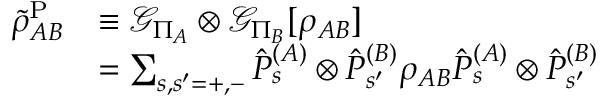<formula> <loc_0><loc_0><loc_500><loc_500>\begin{array} { r l } { \tilde { \rho } _ { A B } ^ { P } } & { \equiv \mathcal { G } _ { \Pi _ { A } } \otimes \mathcal { G } _ { \Pi _ { B } } [ \rho _ { A B } ] } \\ & { = \sum _ { s , s ^ { \prime } = + , - } \hat { P } _ { s } ^ { ( A ) } \otimes \hat { P } _ { s ^ { \prime } } ^ { ( B ) } \rho _ { A B } \hat { P } _ { s } ^ { ( A ) } \otimes \hat { P } _ { s ^ { \prime } } ^ { ( B ) } } \end{array}</formula> 